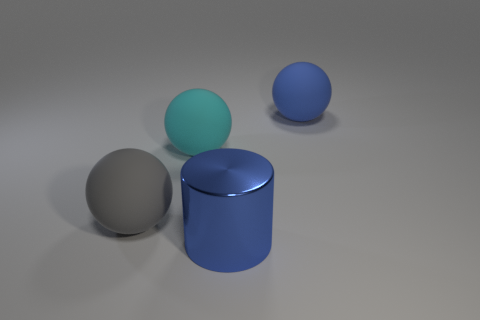Can you tell me what colors are present in this image? The image displays objects in a range of colors. There is a large blue ball and a blue cylindrical object, both displaying different shades of blue. Additionally, there is a silver or light gray sphere, and lastly, an object that appears teal or light greenish-blue in color. 